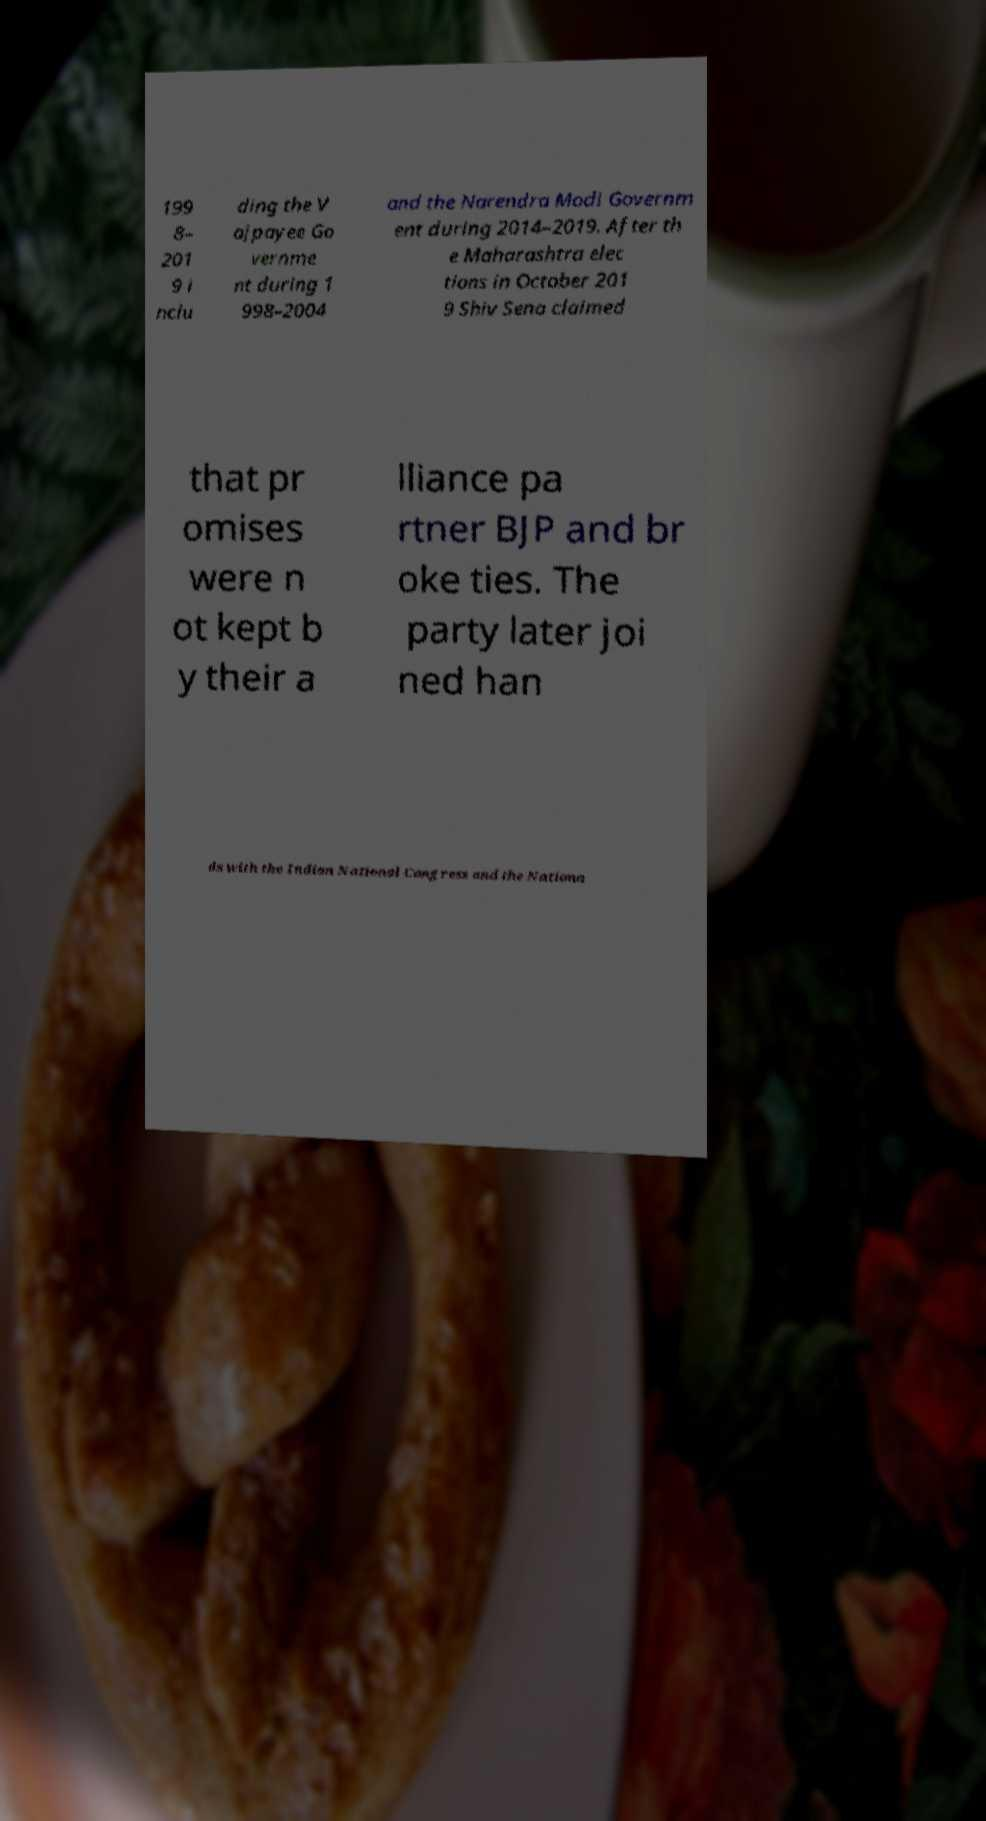Could you extract and type out the text from this image? 199 8– 201 9 i nclu ding the V ajpayee Go vernme nt during 1 998–2004 and the Narendra Modi Governm ent during 2014–2019. After th e Maharashtra elec tions in October 201 9 Shiv Sena claimed that pr omises were n ot kept b y their a lliance pa rtner BJP and br oke ties. The party later joi ned han ds with the Indian National Congress and the Nationa 